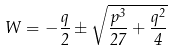<formula> <loc_0><loc_0><loc_500><loc_500>W = - { \frac { q } { 2 } } \pm { \sqrt { { \frac { p ^ { 3 } } { 2 7 } } + { \frac { q ^ { 2 } } { 4 } } } }</formula> 